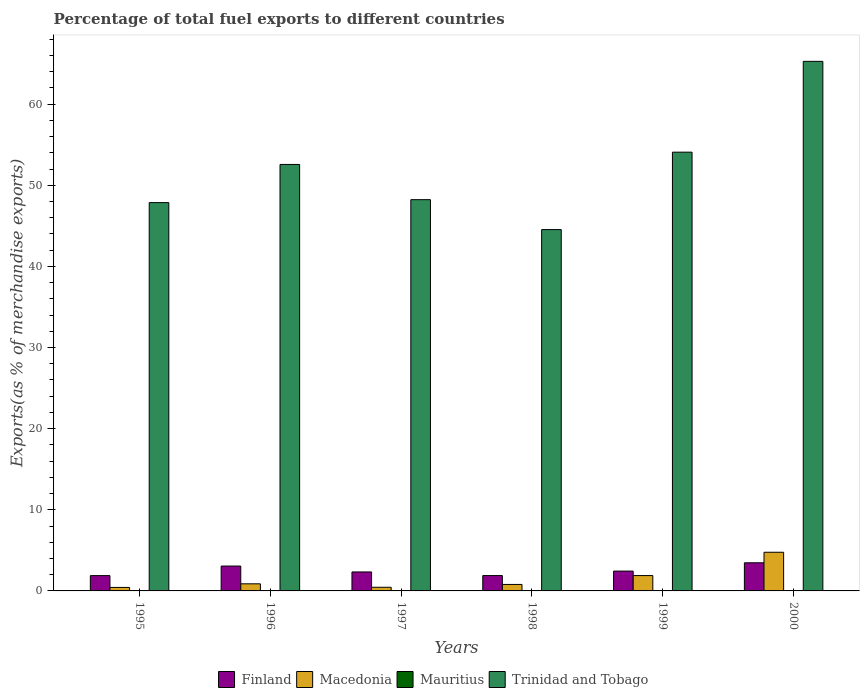How many different coloured bars are there?
Make the answer very short. 4. How many groups of bars are there?
Offer a terse response. 6. Are the number of bars per tick equal to the number of legend labels?
Provide a succinct answer. Yes. What is the label of the 2nd group of bars from the left?
Make the answer very short. 1996. What is the percentage of exports to different countries in Macedonia in 1998?
Give a very brief answer. 0.8. Across all years, what is the maximum percentage of exports to different countries in Finland?
Your response must be concise. 3.47. Across all years, what is the minimum percentage of exports to different countries in Macedonia?
Offer a terse response. 0.43. In which year was the percentage of exports to different countries in Trinidad and Tobago minimum?
Provide a short and direct response. 1998. What is the total percentage of exports to different countries in Trinidad and Tobago in the graph?
Ensure brevity in your answer.  312.57. What is the difference between the percentage of exports to different countries in Trinidad and Tobago in 1995 and that in 1998?
Give a very brief answer. 3.32. What is the difference between the percentage of exports to different countries in Mauritius in 1997 and the percentage of exports to different countries in Finland in 1996?
Offer a very short reply. -3.03. What is the average percentage of exports to different countries in Mauritius per year?
Offer a terse response. 0.02. In the year 1999, what is the difference between the percentage of exports to different countries in Trinidad and Tobago and percentage of exports to different countries in Macedonia?
Provide a succinct answer. 52.19. What is the ratio of the percentage of exports to different countries in Mauritius in 1997 to that in 2000?
Your response must be concise. 4.1. What is the difference between the highest and the second highest percentage of exports to different countries in Trinidad and Tobago?
Ensure brevity in your answer.  11.19. What is the difference between the highest and the lowest percentage of exports to different countries in Finland?
Give a very brief answer. 1.58. Is it the case that in every year, the sum of the percentage of exports to different countries in Macedonia and percentage of exports to different countries in Trinidad and Tobago is greater than the sum of percentage of exports to different countries in Finland and percentage of exports to different countries in Mauritius?
Ensure brevity in your answer.  Yes. What does the 3rd bar from the right in 2000 represents?
Offer a very short reply. Macedonia. Are all the bars in the graph horizontal?
Offer a terse response. No. Are the values on the major ticks of Y-axis written in scientific E-notation?
Make the answer very short. No. Where does the legend appear in the graph?
Make the answer very short. Bottom center. What is the title of the graph?
Make the answer very short. Percentage of total fuel exports to different countries. What is the label or title of the X-axis?
Provide a succinct answer. Years. What is the label or title of the Y-axis?
Ensure brevity in your answer.  Exports(as % of merchandise exports). What is the Exports(as % of merchandise exports) of Finland in 1995?
Provide a succinct answer. 1.89. What is the Exports(as % of merchandise exports) in Macedonia in 1995?
Give a very brief answer. 0.43. What is the Exports(as % of merchandise exports) in Mauritius in 1995?
Offer a terse response. 0.01. What is the Exports(as % of merchandise exports) in Trinidad and Tobago in 1995?
Give a very brief answer. 47.87. What is the Exports(as % of merchandise exports) of Finland in 1996?
Your answer should be very brief. 3.06. What is the Exports(as % of merchandise exports) of Macedonia in 1996?
Give a very brief answer. 0.88. What is the Exports(as % of merchandise exports) of Mauritius in 1996?
Your response must be concise. 7.544697945039909e-5. What is the Exports(as % of merchandise exports) in Trinidad and Tobago in 1996?
Offer a terse response. 52.57. What is the Exports(as % of merchandise exports) of Finland in 1997?
Your response must be concise. 2.34. What is the Exports(as % of merchandise exports) of Macedonia in 1997?
Give a very brief answer. 0.45. What is the Exports(as % of merchandise exports) in Mauritius in 1997?
Make the answer very short. 0.03. What is the Exports(as % of merchandise exports) in Trinidad and Tobago in 1997?
Make the answer very short. 48.23. What is the Exports(as % of merchandise exports) in Finland in 1998?
Offer a terse response. 1.89. What is the Exports(as % of merchandise exports) of Macedonia in 1998?
Your answer should be very brief. 0.8. What is the Exports(as % of merchandise exports) in Mauritius in 1998?
Keep it short and to the point. 0.05. What is the Exports(as % of merchandise exports) of Trinidad and Tobago in 1998?
Make the answer very short. 44.54. What is the Exports(as % of merchandise exports) of Finland in 1999?
Offer a very short reply. 2.45. What is the Exports(as % of merchandise exports) in Macedonia in 1999?
Give a very brief answer. 1.89. What is the Exports(as % of merchandise exports) of Mauritius in 1999?
Ensure brevity in your answer.  0. What is the Exports(as % of merchandise exports) of Trinidad and Tobago in 1999?
Your answer should be compact. 54.08. What is the Exports(as % of merchandise exports) in Finland in 2000?
Give a very brief answer. 3.47. What is the Exports(as % of merchandise exports) of Macedonia in 2000?
Provide a short and direct response. 4.77. What is the Exports(as % of merchandise exports) in Mauritius in 2000?
Provide a short and direct response. 0.01. What is the Exports(as % of merchandise exports) of Trinidad and Tobago in 2000?
Make the answer very short. 65.28. Across all years, what is the maximum Exports(as % of merchandise exports) of Finland?
Ensure brevity in your answer.  3.47. Across all years, what is the maximum Exports(as % of merchandise exports) of Macedonia?
Offer a very short reply. 4.77. Across all years, what is the maximum Exports(as % of merchandise exports) in Mauritius?
Offer a very short reply. 0.05. Across all years, what is the maximum Exports(as % of merchandise exports) in Trinidad and Tobago?
Ensure brevity in your answer.  65.28. Across all years, what is the minimum Exports(as % of merchandise exports) of Finland?
Give a very brief answer. 1.89. Across all years, what is the minimum Exports(as % of merchandise exports) in Macedonia?
Ensure brevity in your answer.  0.43. Across all years, what is the minimum Exports(as % of merchandise exports) in Mauritius?
Keep it short and to the point. 7.544697945039909e-5. Across all years, what is the minimum Exports(as % of merchandise exports) of Trinidad and Tobago?
Your answer should be compact. 44.54. What is the total Exports(as % of merchandise exports) of Finland in the graph?
Your answer should be compact. 15.1. What is the total Exports(as % of merchandise exports) in Macedonia in the graph?
Provide a succinct answer. 9.21. What is the total Exports(as % of merchandise exports) of Mauritius in the graph?
Your answer should be very brief. 0.1. What is the total Exports(as % of merchandise exports) of Trinidad and Tobago in the graph?
Ensure brevity in your answer.  312.57. What is the difference between the Exports(as % of merchandise exports) of Finland in 1995 and that in 1996?
Your response must be concise. -1.18. What is the difference between the Exports(as % of merchandise exports) of Macedonia in 1995 and that in 1996?
Ensure brevity in your answer.  -0.45. What is the difference between the Exports(as % of merchandise exports) in Mauritius in 1995 and that in 1996?
Ensure brevity in your answer.  0.01. What is the difference between the Exports(as % of merchandise exports) of Trinidad and Tobago in 1995 and that in 1996?
Keep it short and to the point. -4.7. What is the difference between the Exports(as % of merchandise exports) in Finland in 1995 and that in 1997?
Your answer should be very brief. -0.45. What is the difference between the Exports(as % of merchandise exports) of Macedonia in 1995 and that in 1997?
Offer a very short reply. -0.02. What is the difference between the Exports(as % of merchandise exports) in Mauritius in 1995 and that in 1997?
Give a very brief answer. -0.03. What is the difference between the Exports(as % of merchandise exports) of Trinidad and Tobago in 1995 and that in 1997?
Offer a terse response. -0.36. What is the difference between the Exports(as % of merchandise exports) in Finland in 1995 and that in 1998?
Make the answer very short. -0.01. What is the difference between the Exports(as % of merchandise exports) of Macedonia in 1995 and that in 1998?
Your answer should be compact. -0.37. What is the difference between the Exports(as % of merchandise exports) in Mauritius in 1995 and that in 1998?
Provide a short and direct response. -0.04. What is the difference between the Exports(as % of merchandise exports) in Trinidad and Tobago in 1995 and that in 1998?
Your answer should be very brief. 3.32. What is the difference between the Exports(as % of merchandise exports) in Finland in 1995 and that in 1999?
Offer a terse response. -0.56. What is the difference between the Exports(as % of merchandise exports) of Macedonia in 1995 and that in 1999?
Provide a succinct answer. -1.46. What is the difference between the Exports(as % of merchandise exports) of Mauritius in 1995 and that in 1999?
Keep it short and to the point. 0.01. What is the difference between the Exports(as % of merchandise exports) of Trinidad and Tobago in 1995 and that in 1999?
Provide a succinct answer. -6.22. What is the difference between the Exports(as % of merchandise exports) in Finland in 1995 and that in 2000?
Make the answer very short. -1.58. What is the difference between the Exports(as % of merchandise exports) in Macedonia in 1995 and that in 2000?
Ensure brevity in your answer.  -4.34. What is the difference between the Exports(as % of merchandise exports) of Mauritius in 1995 and that in 2000?
Ensure brevity in your answer.  -0. What is the difference between the Exports(as % of merchandise exports) in Trinidad and Tobago in 1995 and that in 2000?
Your answer should be compact. -17.41. What is the difference between the Exports(as % of merchandise exports) in Finland in 1996 and that in 1997?
Ensure brevity in your answer.  0.72. What is the difference between the Exports(as % of merchandise exports) of Macedonia in 1996 and that in 1997?
Provide a succinct answer. 0.43. What is the difference between the Exports(as % of merchandise exports) of Mauritius in 1996 and that in 1997?
Your answer should be compact. -0.03. What is the difference between the Exports(as % of merchandise exports) in Trinidad and Tobago in 1996 and that in 1997?
Keep it short and to the point. 4.34. What is the difference between the Exports(as % of merchandise exports) of Finland in 1996 and that in 1998?
Keep it short and to the point. 1.17. What is the difference between the Exports(as % of merchandise exports) of Macedonia in 1996 and that in 1998?
Make the answer very short. 0.08. What is the difference between the Exports(as % of merchandise exports) in Mauritius in 1996 and that in 1998?
Ensure brevity in your answer.  -0.05. What is the difference between the Exports(as % of merchandise exports) of Trinidad and Tobago in 1996 and that in 1998?
Keep it short and to the point. 8.03. What is the difference between the Exports(as % of merchandise exports) of Finland in 1996 and that in 1999?
Your answer should be very brief. 0.62. What is the difference between the Exports(as % of merchandise exports) in Macedonia in 1996 and that in 1999?
Keep it short and to the point. -1.02. What is the difference between the Exports(as % of merchandise exports) of Mauritius in 1996 and that in 1999?
Offer a terse response. -0. What is the difference between the Exports(as % of merchandise exports) in Trinidad and Tobago in 1996 and that in 1999?
Keep it short and to the point. -1.52. What is the difference between the Exports(as % of merchandise exports) of Finland in 1996 and that in 2000?
Provide a succinct answer. -0.4. What is the difference between the Exports(as % of merchandise exports) in Macedonia in 1996 and that in 2000?
Provide a succinct answer. -3.89. What is the difference between the Exports(as % of merchandise exports) in Mauritius in 1996 and that in 2000?
Provide a succinct answer. -0.01. What is the difference between the Exports(as % of merchandise exports) of Trinidad and Tobago in 1996 and that in 2000?
Offer a very short reply. -12.71. What is the difference between the Exports(as % of merchandise exports) in Finland in 1997 and that in 1998?
Your answer should be compact. 0.45. What is the difference between the Exports(as % of merchandise exports) in Macedonia in 1997 and that in 1998?
Offer a very short reply. -0.35. What is the difference between the Exports(as % of merchandise exports) of Mauritius in 1997 and that in 1998?
Ensure brevity in your answer.  -0.02. What is the difference between the Exports(as % of merchandise exports) of Trinidad and Tobago in 1997 and that in 1998?
Offer a very short reply. 3.69. What is the difference between the Exports(as % of merchandise exports) in Finland in 1997 and that in 1999?
Give a very brief answer. -0.11. What is the difference between the Exports(as % of merchandise exports) of Macedonia in 1997 and that in 1999?
Your answer should be very brief. -1.44. What is the difference between the Exports(as % of merchandise exports) of Mauritius in 1997 and that in 1999?
Give a very brief answer. 0.03. What is the difference between the Exports(as % of merchandise exports) of Trinidad and Tobago in 1997 and that in 1999?
Make the answer very short. -5.86. What is the difference between the Exports(as % of merchandise exports) of Finland in 1997 and that in 2000?
Your answer should be compact. -1.13. What is the difference between the Exports(as % of merchandise exports) of Macedonia in 1997 and that in 2000?
Keep it short and to the point. -4.32. What is the difference between the Exports(as % of merchandise exports) of Mauritius in 1997 and that in 2000?
Provide a succinct answer. 0.03. What is the difference between the Exports(as % of merchandise exports) in Trinidad and Tobago in 1997 and that in 2000?
Provide a succinct answer. -17.05. What is the difference between the Exports(as % of merchandise exports) of Finland in 1998 and that in 1999?
Your answer should be compact. -0.55. What is the difference between the Exports(as % of merchandise exports) in Macedonia in 1998 and that in 1999?
Provide a short and direct response. -1.1. What is the difference between the Exports(as % of merchandise exports) of Mauritius in 1998 and that in 1999?
Provide a short and direct response. 0.05. What is the difference between the Exports(as % of merchandise exports) of Trinidad and Tobago in 1998 and that in 1999?
Offer a terse response. -9.54. What is the difference between the Exports(as % of merchandise exports) of Finland in 1998 and that in 2000?
Make the answer very short. -1.57. What is the difference between the Exports(as % of merchandise exports) of Macedonia in 1998 and that in 2000?
Make the answer very short. -3.97. What is the difference between the Exports(as % of merchandise exports) of Mauritius in 1998 and that in 2000?
Provide a short and direct response. 0.04. What is the difference between the Exports(as % of merchandise exports) of Trinidad and Tobago in 1998 and that in 2000?
Make the answer very short. -20.74. What is the difference between the Exports(as % of merchandise exports) of Finland in 1999 and that in 2000?
Keep it short and to the point. -1.02. What is the difference between the Exports(as % of merchandise exports) in Macedonia in 1999 and that in 2000?
Provide a succinct answer. -2.87. What is the difference between the Exports(as % of merchandise exports) of Mauritius in 1999 and that in 2000?
Your answer should be very brief. -0.01. What is the difference between the Exports(as % of merchandise exports) in Trinidad and Tobago in 1999 and that in 2000?
Keep it short and to the point. -11.19. What is the difference between the Exports(as % of merchandise exports) in Finland in 1995 and the Exports(as % of merchandise exports) in Macedonia in 1996?
Offer a very short reply. 1.01. What is the difference between the Exports(as % of merchandise exports) of Finland in 1995 and the Exports(as % of merchandise exports) of Mauritius in 1996?
Keep it short and to the point. 1.89. What is the difference between the Exports(as % of merchandise exports) in Finland in 1995 and the Exports(as % of merchandise exports) in Trinidad and Tobago in 1996?
Offer a very short reply. -50.68. What is the difference between the Exports(as % of merchandise exports) in Macedonia in 1995 and the Exports(as % of merchandise exports) in Mauritius in 1996?
Offer a terse response. 0.43. What is the difference between the Exports(as % of merchandise exports) of Macedonia in 1995 and the Exports(as % of merchandise exports) of Trinidad and Tobago in 1996?
Keep it short and to the point. -52.14. What is the difference between the Exports(as % of merchandise exports) in Mauritius in 1995 and the Exports(as % of merchandise exports) in Trinidad and Tobago in 1996?
Give a very brief answer. -52.56. What is the difference between the Exports(as % of merchandise exports) in Finland in 1995 and the Exports(as % of merchandise exports) in Macedonia in 1997?
Your answer should be very brief. 1.44. What is the difference between the Exports(as % of merchandise exports) in Finland in 1995 and the Exports(as % of merchandise exports) in Mauritius in 1997?
Your response must be concise. 1.85. What is the difference between the Exports(as % of merchandise exports) of Finland in 1995 and the Exports(as % of merchandise exports) of Trinidad and Tobago in 1997?
Offer a terse response. -46.34. What is the difference between the Exports(as % of merchandise exports) in Macedonia in 1995 and the Exports(as % of merchandise exports) in Mauritius in 1997?
Make the answer very short. 0.4. What is the difference between the Exports(as % of merchandise exports) in Macedonia in 1995 and the Exports(as % of merchandise exports) in Trinidad and Tobago in 1997?
Provide a short and direct response. -47.8. What is the difference between the Exports(as % of merchandise exports) of Mauritius in 1995 and the Exports(as % of merchandise exports) of Trinidad and Tobago in 1997?
Provide a short and direct response. -48.22. What is the difference between the Exports(as % of merchandise exports) in Finland in 1995 and the Exports(as % of merchandise exports) in Macedonia in 1998?
Make the answer very short. 1.09. What is the difference between the Exports(as % of merchandise exports) of Finland in 1995 and the Exports(as % of merchandise exports) of Mauritius in 1998?
Your answer should be compact. 1.84. What is the difference between the Exports(as % of merchandise exports) in Finland in 1995 and the Exports(as % of merchandise exports) in Trinidad and Tobago in 1998?
Give a very brief answer. -42.65. What is the difference between the Exports(as % of merchandise exports) of Macedonia in 1995 and the Exports(as % of merchandise exports) of Mauritius in 1998?
Ensure brevity in your answer.  0.38. What is the difference between the Exports(as % of merchandise exports) in Macedonia in 1995 and the Exports(as % of merchandise exports) in Trinidad and Tobago in 1998?
Provide a short and direct response. -44.11. What is the difference between the Exports(as % of merchandise exports) in Mauritius in 1995 and the Exports(as % of merchandise exports) in Trinidad and Tobago in 1998?
Offer a very short reply. -44.53. What is the difference between the Exports(as % of merchandise exports) in Finland in 1995 and the Exports(as % of merchandise exports) in Macedonia in 1999?
Your response must be concise. -0.01. What is the difference between the Exports(as % of merchandise exports) in Finland in 1995 and the Exports(as % of merchandise exports) in Mauritius in 1999?
Offer a very short reply. 1.89. What is the difference between the Exports(as % of merchandise exports) of Finland in 1995 and the Exports(as % of merchandise exports) of Trinidad and Tobago in 1999?
Provide a succinct answer. -52.2. What is the difference between the Exports(as % of merchandise exports) of Macedonia in 1995 and the Exports(as % of merchandise exports) of Mauritius in 1999?
Ensure brevity in your answer.  0.43. What is the difference between the Exports(as % of merchandise exports) of Macedonia in 1995 and the Exports(as % of merchandise exports) of Trinidad and Tobago in 1999?
Make the answer very short. -53.65. What is the difference between the Exports(as % of merchandise exports) in Mauritius in 1995 and the Exports(as % of merchandise exports) in Trinidad and Tobago in 1999?
Give a very brief answer. -54.08. What is the difference between the Exports(as % of merchandise exports) in Finland in 1995 and the Exports(as % of merchandise exports) in Macedonia in 2000?
Ensure brevity in your answer.  -2.88. What is the difference between the Exports(as % of merchandise exports) of Finland in 1995 and the Exports(as % of merchandise exports) of Mauritius in 2000?
Ensure brevity in your answer.  1.88. What is the difference between the Exports(as % of merchandise exports) of Finland in 1995 and the Exports(as % of merchandise exports) of Trinidad and Tobago in 2000?
Make the answer very short. -63.39. What is the difference between the Exports(as % of merchandise exports) in Macedonia in 1995 and the Exports(as % of merchandise exports) in Mauritius in 2000?
Provide a short and direct response. 0.42. What is the difference between the Exports(as % of merchandise exports) of Macedonia in 1995 and the Exports(as % of merchandise exports) of Trinidad and Tobago in 2000?
Offer a terse response. -64.85. What is the difference between the Exports(as % of merchandise exports) in Mauritius in 1995 and the Exports(as % of merchandise exports) in Trinidad and Tobago in 2000?
Your response must be concise. -65.27. What is the difference between the Exports(as % of merchandise exports) of Finland in 1996 and the Exports(as % of merchandise exports) of Macedonia in 1997?
Offer a very short reply. 2.62. What is the difference between the Exports(as % of merchandise exports) of Finland in 1996 and the Exports(as % of merchandise exports) of Mauritius in 1997?
Your answer should be compact. 3.03. What is the difference between the Exports(as % of merchandise exports) of Finland in 1996 and the Exports(as % of merchandise exports) of Trinidad and Tobago in 1997?
Keep it short and to the point. -45.16. What is the difference between the Exports(as % of merchandise exports) in Macedonia in 1996 and the Exports(as % of merchandise exports) in Mauritius in 1997?
Your answer should be very brief. 0.84. What is the difference between the Exports(as % of merchandise exports) of Macedonia in 1996 and the Exports(as % of merchandise exports) of Trinidad and Tobago in 1997?
Give a very brief answer. -47.35. What is the difference between the Exports(as % of merchandise exports) in Mauritius in 1996 and the Exports(as % of merchandise exports) in Trinidad and Tobago in 1997?
Offer a very short reply. -48.23. What is the difference between the Exports(as % of merchandise exports) of Finland in 1996 and the Exports(as % of merchandise exports) of Macedonia in 1998?
Offer a terse response. 2.27. What is the difference between the Exports(as % of merchandise exports) in Finland in 1996 and the Exports(as % of merchandise exports) in Mauritius in 1998?
Provide a short and direct response. 3.01. What is the difference between the Exports(as % of merchandise exports) of Finland in 1996 and the Exports(as % of merchandise exports) of Trinidad and Tobago in 1998?
Offer a very short reply. -41.48. What is the difference between the Exports(as % of merchandise exports) of Macedonia in 1996 and the Exports(as % of merchandise exports) of Mauritius in 1998?
Your answer should be very brief. 0.82. What is the difference between the Exports(as % of merchandise exports) in Macedonia in 1996 and the Exports(as % of merchandise exports) in Trinidad and Tobago in 1998?
Offer a terse response. -43.67. What is the difference between the Exports(as % of merchandise exports) of Mauritius in 1996 and the Exports(as % of merchandise exports) of Trinidad and Tobago in 1998?
Make the answer very short. -44.54. What is the difference between the Exports(as % of merchandise exports) in Finland in 1996 and the Exports(as % of merchandise exports) in Macedonia in 1999?
Keep it short and to the point. 1.17. What is the difference between the Exports(as % of merchandise exports) of Finland in 1996 and the Exports(as % of merchandise exports) of Mauritius in 1999?
Your answer should be compact. 3.06. What is the difference between the Exports(as % of merchandise exports) of Finland in 1996 and the Exports(as % of merchandise exports) of Trinidad and Tobago in 1999?
Your answer should be very brief. -51.02. What is the difference between the Exports(as % of merchandise exports) of Macedonia in 1996 and the Exports(as % of merchandise exports) of Mauritius in 1999?
Your response must be concise. 0.87. What is the difference between the Exports(as % of merchandise exports) of Macedonia in 1996 and the Exports(as % of merchandise exports) of Trinidad and Tobago in 1999?
Your answer should be compact. -53.21. What is the difference between the Exports(as % of merchandise exports) in Mauritius in 1996 and the Exports(as % of merchandise exports) in Trinidad and Tobago in 1999?
Keep it short and to the point. -54.08. What is the difference between the Exports(as % of merchandise exports) of Finland in 1996 and the Exports(as % of merchandise exports) of Macedonia in 2000?
Make the answer very short. -1.7. What is the difference between the Exports(as % of merchandise exports) in Finland in 1996 and the Exports(as % of merchandise exports) in Mauritius in 2000?
Offer a terse response. 3.06. What is the difference between the Exports(as % of merchandise exports) of Finland in 1996 and the Exports(as % of merchandise exports) of Trinidad and Tobago in 2000?
Make the answer very short. -62.21. What is the difference between the Exports(as % of merchandise exports) of Macedonia in 1996 and the Exports(as % of merchandise exports) of Mauritius in 2000?
Your answer should be very brief. 0.87. What is the difference between the Exports(as % of merchandise exports) of Macedonia in 1996 and the Exports(as % of merchandise exports) of Trinidad and Tobago in 2000?
Your answer should be very brief. -64.4. What is the difference between the Exports(as % of merchandise exports) of Mauritius in 1996 and the Exports(as % of merchandise exports) of Trinidad and Tobago in 2000?
Make the answer very short. -65.28. What is the difference between the Exports(as % of merchandise exports) of Finland in 1997 and the Exports(as % of merchandise exports) of Macedonia in 1998?
Keep it short and to the point. 1.54. What is the difference between the Exports(as % of merchandise exports) in Finland in 1997 and the Exports(as % of merchandise exports) in Mauritius in 1998?
Provide a succinct answer. 2.29. What is the difference between the Exports(as % of merchandise exports) in Finland in 1997 and the Exports(as % of merchandise exports) in Trinidad and Tobago in 1998?
Your answer should be compact. -42.2. What is the difference between the Exports(as % of merchandise exports) in Macedonia in 1997 and the Exports(as % of merchandise exports) in Mauritius in 1998?
Make the answer very short. 0.4. What is the difference between the Exports(as % of merchandise exports) in Macedonia in 1997 and the Exports(as % of merchandise exports) in Trinidad and Tobago in 1998?
Keep it short and to the point. -44.09. What is the difference between the Exports(as % of merchandise exports) in Mauritius in 1997 and the Exports(as % of merchandise exports) in Trinidad and Tobago in 1998?
Make the answer very short. -44.51. What is the difference between the Exports(as % of merchandise exports) in Finland in 1997 and the Exports(as % of merchandise exports) in Macedonia in 1999?
Your answer should be compact. 0.45. What is the difference between the Exports(as % of merchandise exports) of Finland in 1997 and the Exports(as % of merchandise exports) of Mauritius in 1999?
Provide a short and direct response. 2.34. What is the difference between the Exports(as % of merchandise exports) of Finland in 1997 and the Exports(as % of merchandise exports) of Trinidad and Tobago in 1999?
Offer a terse response. -51.74. What is the difference between the Exports(as % of merchandise exports) of Macedonia in 1997 and the Exports(as % of merchandise exports) of Mauritius in 1999?
Your answer should be very brief. 0.45. What is the difference between the Exports(as % of merchandise exports) in Macedonia in 1997 and the Exports(as % of merchandise exports) in Trinidad and Tobago in 1999?
Offer a very short reply. -53.64. What is the difference between the Exports(as % of merchandise exports) in Mauritius in 1997 and the Exports(as % of merchandise exports) in Trinidad and Tobago in 1999?
Your answer should be compact. -54.05. What is the difference between the Exports(as % of merchandise exports) in Finland in 1997 and the Exports(as % of merchandise exports) in Macedonia in 2000?
Offer a very short reply. -2.43. What is the difference between the Exports(as % of merchandise exports) of Finland in 1997 and the Exports(as % of merchandise exports) of Mauritius in 2000?
Your answer should be compact. 2.33. What is the difference between the Exports(as % of merchandise exports) of Finland in 1997 and the Exports(as % of merchandise exports) of Trinidad and Tobago in 2000?
Provide a succinct answer. -62.94. What is the difference between the Exports(as % of merchandise exports) in Macedonia in 1997 and the Exports(as % of merchandise exports) in Mauritius in 2000?
Keep it short and to the point. 0.44. What is the difference between the Exports(as % of merchandise exports) of Macedonia in 1997 and the Exports(as % of merchandise exports) of Trinidad and Tobago in 2000?
Provide a succinct answer. -64.83. What is the difference between the Exports(as % of merchandise exports) of Mauritius in 1997 and the Exports(as % of merchandise exports) of Trinidad and Tobago in 2000?
Provide a succinct answer. -65.24. What is the difference between the Exports(as % of merchandise exports) in Finland in 1998 and the Exports(as % of merchandise exports) in Macedonia in 1999?
Give a very brief answer. -0. What is the difference between the Exports(as % of merchandise exports) in Finland in 1998 and the Exports(as % of merchandise exports) in Mauritius in 1999?
Provide a short and direct response. 1.89. What is the difference between the Exports(as % of merchandise exports) of Finland in 1998 and the Exports(as % of merchandise exports) of Trinidad and Tobago in 1999?
Make the answer very short. -52.19. What is the difference between the Exports(as % of merchandise exports) in Macedonia in 1998 and the Exports(as % of merchandise exports) in Mauritius in 1999?
Your response must be concise. 0.8. What is the difference between the Exports(as % of merchandise exports) of Macedonia in 1998 and the Exports(as % of merchandise exports) of Trinidad and Tobago in 1999?
Provide a short and direct response. -53.29. What is the difference between the Exports(as % of merchandise exports) in Mauritius in 1998 and the Exports(as % of merchandise exports) in Trinidad and Tobago in 1999?
Offer a terse response. -54.03. What is the difference between the Exports(as % of merchandise exports) of Finland in 1998 and the Exports(as % of merchandise exports) of Macedonia in 2000?
Your answer should be very brief. -2.87. What is the difference between the Exports(as % of merchandise exports) in Finland in 1998 and the Exports(as % of merchandise exports) in Mauritius in 2000?
Offer a very short reply. 1.88. What is the difference between the Exports(as % of merchandise exports) in Finland in 1998 and the Exports(as % of merchandise exports) in Trinidad and Tobago in 2000?
Make the answer very short. -63.39. What is the difference between the Exports(as % of merchandise exports) of Macedonia in 1998 and the Exports(as % of merchandise exports) of Mauritius in 2000?
Your answer should be compact. 0.79. What is the difference between the Exports(as % of merchandise exports) of Macedonia in 1998 and the Exports(as % of merchandise exports) of Trinidad and Tobago in 2000?
Give a very brief answer. -64.48. What is the difference between the Exports(as % of merchandise exports) of Mauritius in 1998 and the Exports(as % of merchandise exports) of Trinidad and Tobago in 2000?
Offer a terse response. -65.23. What is the difference between the Exports(as % of merchandise exports) of Finland in 1999 and the Exports(as % of merchandise exports) of Macedonia in 2000?
Your answer should be compact. -2.32. What is the difference between the Exports(as % of merchandise exports) in Finland in 1999 and the Exports(as % of merchandise exports) in Mauritius in 2000?
Your answer should be very brief. 2.44. What is the difference between the Exports(as % of merchandise exports) in Finland in 1999 and the Exports(as % of merchandise exports) in Trinidad and Tobago in 2000?
Ensure brevity in your answer.  -62.83. What is the difference between the Exports(as % of merchandise exports) in Macedonia in 1999 and the Exports(as % of merchandise exports) in Mauritius in 2000?
Your response must be concise. 1.89. What is the difference between the Exports(as % of merchandise exports) in Macedonia in 1999 and the Exports(as % of merchandise exports) in Trinidad and Tobago in 2000?
Offer a very short reply. -63.38. What is the difference between the Exports(as % of merchandise exports) in Mauritius in 1999 and the Exports(as % of merchandise exports) in Trinidad and Tobago in 2000?
Your answer should be compact. -65.28. What is the average Exports(as % of merchandise exports) of Finland per year?
Your answer should be compact. 2.52. What is the average Exports(as % of merchandise exports) of Macedonia per year?
Your response must be concise. 1.54. What is the average Exports(as % of merchandise exports) of Mauritius per year?
Your answer should be very brief. 0.02. What is the average Exports(as % of merchandise exports) of Trinidad and Tobago per year?
Your answer should be compact. 52.09. In the year 1995, what is the difference between the Exports(as % of merchandise exports) in Finland and Exports(as % of merchandise exports) in Macedonia?
Make the answer very short. 1.46. In the year 1995, what is the difference between the Exports(as % of merchandise exports) of Finland and Exports(as % of merchandise exports) of Mauritius?
Ensure brevity in your answer.  1.88. In the year 1995, what is the difference between the Exports(as % of merchandise exports) in Finland and Exports(as % of merchandise exports) in Trinidad and Tobago?
Keep it short and to the point. -45.98. In the year 1995, what is the difference between the Exports(as % of merchandise exports) of Macedonia and Exports(as % of merchandise exports) of Mauritius?
Keep it short and to the point. 0.42. In the year 1995, what is the difference between the Exports(as % of merchandise exports) in Macedonia and Exports(as % of merchandise exports) in Trinidad and Tobago?
Make the answer very short. -47.44. In the year 1995, what is the difference between the Exports(as % of merchandise exports) of Mauritius and Exports(as % of merchandise exports) of Trinidad and Tobago?
Provide a succinct answer. -47.86. In the year 1996, what is the difference between the Exports(as % of merchandise exports) of Finland and Exports(as % of merchandise exports) of Macedonia?
Your answer should be compact. 2.19. In the year 1996, what is the difference between the Exports(as % of merchandise exports) of Finland and Exports(as % of merchandise exports) of Mauritius?
Your answer should be compact. 3.06. In the year 1996, what is the difference between the Exports(as % of merchandise exports) in Finland and Exports(as % of merchandise exports) in Trinidad and Tobago?
Your response must be concise. -49.5. In the year 1996, what is the difference between the Exports(as % of merchandise exports) of Macedonia and Exports(as % of merchandise exports) of Mauritius?
Offer a very short reply. 0.88. In the year 1996, what is the difference between the Exports(as % of merchandise exports) of Macedonia and Exports(as % of merchandise exports) of Trinidad and Tobago?
Your answer should be compact. -51.69. In the year 1996, what is the difference between the Exports(as % of merchandise exports) in Mauritius and Exports(as % of merchandise exports) in Trinidad and Tobago?
Ensure brevity in your answer.  -52.57. In the year 1997, what is the difference between the Exports(as % of merchandise exports) in Finland and Exports(as % of merchandise exports) in Macedonia?
Your response must be concise. 1.89. In the year 1997, what is the difference between the Exports(as % of merchandise exports) in Finland and Exports(as % of merchandise exports) in Mauritius?
Provide a succinct answer. 2.31. In the year 1997, what is the difference between the Exports(as % of merchandise exports) in Finland and Exports(as % of merchandise exports) in Trinidad and Tobago?
Offer a very short reply. -45.89. In the year 1997, what is the difference between the Exports(as % of merchandise exports) in Macedonia and Exports(as % of merchandise exports) in Mauritius?
Your answer should be compact. 0.42. In the year 1997, what is the difference between the Exports(as % of merchandise exports) in Macedonia and Exports(as % of merchandise exports) in Trinidad and Tobago?
Ensure brevity in your answer.  -47.78. In the year 1997, what is the difference between the Exports(as % of merchandise exports) in Mauritius and Exports(as % of merchandise exports) in Trinidad and Tobago?
Your response must be concise. -48.19. In the year 1998, what is the difference between the Exports(as % of merchandise exports) in Finland and Exports(as % of merchandise exports) in Macedonia?
Offer a very short reply. 1.09. In the year 1998, what is the difference between the Exports(as % of merchandise exports) in Finland and Exports(as % of merchandise exports) in Mauritius?
Provide a succinct answer. 1.84. In the year 1998, what is the difference between the Exports(as % of merchandise exports) of Finland and Exports(as % of merchandise exports) of Trinidad and Tobago?
Your answer should be very brief. -42.65. In the year 1998, what is the difference between the Exports(as % of merchandise exports) in Macedonia and Exports(as % of merchandise exports) in Mauritius?
Provide a short and direct response. 0.75. In the year 1998, what is the difference between the Exports(as % of merchandise exports) in Macedonia and Exports(as % of merchandise exports) in Trinidad and Tobago?
Offer a very short reply. -43.74. In the year 1998, what is the difference between the Exports(as % of merchandise exports) in Mauritius and Exports(as % of merchandise exports) in Trinidad and Tobago?
Your response must be concise. -44.49. In the year 1999, what is the difference between the Exports(as % of merchandise exports) in Finland and Exports(as % of merchandise exports) in Macedonia?
Offer a very short reply. 0.55. In the year 1999, what is the difference between the Exports(as % of merchandise exports) in Finland and Exports(as % of merchandise exports) in Mauritius?
Make the answer very short. 2.44. In the year 1999, what is the difference between the Exports(as % of merchandise exports) of Finland and Exports(as % of merchandise exports) of Trinidad and Tobago?
Make the answer very short. -51.64. In the year 1999, what is the difference between the Exports(as % of merchandise exports) in Macedonia and Exports(as % of merchandise exports) in Mauritius?
Your answer should be very brief. 1.89. In the year 1999, what is the difference between the Exports(as % of merchandise exports) in Macedonia and Exports(as % of merchandise exports) in Trinidad and Tobago?
Your answer should be compact. -52.19. In the year 1999, what is the difference between the Exports(as % of merchandise exports) of Mauritius and Exports(as % of merchandise exports) of Trinidad and Tobago?
Keep it short and to the point. -54.08. In the year 2000, what is the difference between the Exports(as % of merchandise exports) of Finland and Exports(as % of merchandise exports) of Macedonia?
Make the answer very short. -1.3. In the year 2000, what is the difference between the Exports(as % of merchandise exports) in Finland and Exports(as % of merchandise exports) in Mauritius?
Your response must be concise. 3.46. In the year 2000, what is the difference between the Exports(as % of merchandise exports) of Finland and Exports(as % of merchandise exports) of Trinidad and Tobago?
Offer a terse response. -61.81. In the year 2000, what is the difference between the Exports(as % of merchandise exports) in Macedonia and Exports(as % of merchandise exports) in Mauritius?
Provide a succinct answer. 4.76. In the year 2000, what is the difference between the Exports(as % of merchandise exports) of Macedonia and Exports(as % of merchandise exports) of Trinidad and Tobago?
Your response must be concise. -60.51. In the year 2000, what is the difference between the Exports(as % of merchandise exports) in Mauritius and Exports(as % of merchandise exports) in Trinidad and Tobago?
Your answer should be very brief. -65.27. What is the ratio of the Exports(as % of merchandise exports) in Finland in 1995 to that in 1996?
Provide a succinct answer. 0.62. What is the ratio of the Exports(as % of merchandise exports) of Macedonia in 1995 to that in 1996?
Make the answer very short. 0.49. What is the ratio of the Exports(as % of merchandise exports) in Mauritius in 1995 to that in 1996?
Provide a short and direct response. 98.57. What is the ratio of the Exports(as % of merchandise exports) in Trinidad and Tobago in 1995 to that in 1996?
Offer a terse response. 0.91. What is the ratio of the Exports(as % of merchandise exports) of Finland in 1995 to that in 1997?
Provide a succinct answer. 0.81. What is the ratio of the Exports(as % of merchandise exports) in Macedonia in 1995 to that in 1997?
Provide a succinct answer. 0.96. What is the ratio of the Exports(as % of merchandise exports) in Mauritius in 1995 to that in 1997?
Offer a very short reply. 0.22. What is the ratio of the Exports(as % of merchandise exports) of Trinidad and Tobago in 1995 to that in 1997?
Make the answer very short. 0.99. What is the ratio of the Exports(as % of merchandise exports) of Finland in 1995 to that in 1998?
Give a very brief answer. 1. What is the ratio of the Exports(as % of merchandise exports) of Macedonia in 1995 to that in 1998?
Provide a succinct answer. 0.54. What is the ratio of the Exports(as % of merchandise exports) of Mauritius in 1995 to that in 1998?
Offer a terse response. 0.15. What is the ratio of the Exports(as % of merchandise exports) of Trinidad and Tobago in 1995 to that in 1998?
Ensure brevity in your answer.  1.07. What is the ratio of the Exports(as % of merchandise exports) in Finland in 1995 to that in 1999?
Your answer should be very brief. 0.77. What is the ratio of the Exports(as % of merchandise exports) of Macedonia in 1995 to that in 1999?
Offer a very short reply. 0.23. What is the ratio of the Exports(as % of merchandise exports) in Mauritius in 1995 to that in 1999?
Your response must be concise. 5.86. What is the ratio of the Exports(as % of merchandise exports) of Trinidad and Tobago in 1995 to that in 1999?
Your response must be concise. 0.89. What is the ratio of the Exports(as % of merchandise exports) of Finland in 1995 to that in 2000?
Your answer should be very brief. 0.54. What is the ratio of the Exports(as % of merchandise exports) of Macedonia in 1995 to that in 2000?
Make the answer very short. 0.09. What is the ratio of the Exports(as % of merchandise exports) of Mauritius in 1995 to that in 2000?
Provide a succinct answer. 0.9. What is the ratio of the Exports(as % of merchandise exports) in Trinidad and Tobago in 1995 to that in 2000?
Make the answer very short. 0.73. What is the ratio of the Exports(as % of merchandise exports) of Finland in 1996 to that in 1997?
Your response must be concise. 1.31. What is the ratio of the Exports(as % of merchandise exports) of Macedonia in 1996 to that in 1997?
Give a very brief answer. 1.95. What is the ratio of the Exports(as % of merchandise exports) of Mauritius in 1996 to that in 1997?
Give a very brief answer. 0. What is the ratio of the Exports(as % of merchandise exports) of Trinidad and Tobago in 1996 to that in 1997?
Give a very brief answer. 1.09. What is the ratio of the Exports(as % of merchandise exports) of Finland in 1996 to that in 1998?
Your response must be concise. 1.62. What is the ratio of the Exports(as % of merchandise exports) in Macedonia in 1996 to that in 1998?
Provide a short and direct response. 1.1. What is the ratio of the Exports(as % of merchandise exports) in Mauritius in 1996 to that in 1998?
Provide a short and direct response. 0. What is the ratio of the Exports(as % of merchandise exports) of Trinidad and Tobago in 1996 to that in 1998?
Your answer should be very brief. 1.18. What is the ratio of the Exports(as % of merchandise exports) of Finland in 1996 to that in 1999?
Provide a succinct answer. 1.25. What is the ratio of the Exports(as % of merchandise exports) of Macedonia in 1996 to that in 1999?
Provide a short and direct response. 0.46. What is the ratio of the Exports(as % of merchandise exports) of Mauritius in 1996 to that in 1999?
Offer a very short reply. 0.06. What is the ratio of the Exports(as % of merchandise exports) of Finland in 1996 to that in 2000?
Offer a terse response. 0.88. What is the ratio of the Exports(as % of merchandise exports) in Macedonia in 1996 to that in 2000?
Your response must be concise. 0.18. What is the ratio of the Exports(as % of merchandise exports) of Mauritius in 1996 to that in 2000?
Keep it short and to the point. 0.01. What is the ratio of the Exports(as % of merchandise exports) of Trinidad and Tobago in 1996 to that in 2000?
Ensure brevity in your answer.  0.81. What is the ratio of the Exports(as % of merchandise exports) of Finland in 1997 to that in 1998?
Your answer should be compact. 1.24. What is the ratio of the Exports(as % of merchandise exports) in Macedonia in 1997 to that in 1998?
Offer a terse response. 0.56. What is the ratio of the Exports(as % of merchandise exports) of Mauritius in 1997 to that in 1998?
Offer a terse response. 0.67. What is the ratio of the Exports(as % of merchandise exports) in Trinidad and Tobago in 1997 to that in 1998?
Provide a succinct answer. 1.08. What is the ratio of the Exports(as % of merchandise exports) of Finland in 1997 to that in 1999?
Offer a terse response. 0.96. What is the ratio of the Exports(as % of merchandise exports) of Macedonia in 1997 to that in 1999?
Keep it short and to the point. 0.24. What is the ratio of the Exports(as % of merchandise exports) of Mauritius in 1997 to that in 1999?
Your answer should be compact. 26.56. What is the ratio of the Exports(as % of merchandise exports) in Trinidad and Tobago in 1997 to that in 1999?
Keep it short and to the point. 0.89. What is the ratio of the Exports(as % of merchandise exports) of Finland in 1997 to that in 2000?
Your answer should be compact. 0.68. What is the ratio of the Exports(as % of merchandise exports) in Macedonia in 1997 to that in 2000?
Offer a very short reply. 0.09. What is the ratio of the Exports(as % of merchandise exports) of Mauritius in 1997 to that in 2000?
Give a very brief answer. 4.1. What is the ratio of the Exports(as % of merchandise exports) of Trinidad and Tobago in 1997 to that in 2000?
Your response must be concise. 0.74. What is the ratio of the Exports(as % of merchandise exports) in Finland in 1998 to that in 1999?
Provide a succinct answer. 0.77. What is the ratio of the Exports(as % of merchandise exports) in Macedonia in 1998 to that in 1999?
Make the answer very short. 0.42. What is the ratio of the Exports(as % of merchandise exports) of Mauritius in 1998 to that in 1999?
Your response must be concise. 39.67. What is the ratio of the Exports(as % of merchandise exports) of Trinidad and Tobago in 1998 to that in 1999?
Keep it short and to the point. 0.82. What is the ratio of the Exports(as % of merchandise exports) of Finland in 1998 to that in 2000?
Make the answer very short. 0.55. What is the ratio of the Exports(as % of merchandise exports) of Macedonia in 1998 to that in 2000?
Keep it short and to the point. 0.17. What is the ratio of the Exports(as % of merchandise exports) in Mauritius in 1998 to that in 2000?
Your answer should be compact. 6.12. What is the ratio of the Exports(as % of merchandise exports) of Trinidad and Tobago in 1998 to that in 2000?
Your response must be concise. 0.68. What is the ratio of the Exports(as % of merchandise exports) in Finland in 1999 to that in 2000?
Make the answer very short. 0.71. What is the ratio of the Exports(as % of merchandise exports) of Macedonia in 1999 to that in 2000?
Keep it short and to the point. 0.4. What is the ratio of the Exports(as % of merchandise exports) in Mauritius in 1999 to that in 2000?
Your answer should be very brief. 0.15. What is the ratio of the Exports(as % of merchandise exports) of Trinidad and Tobago in 1999 to that in 2000?
Keep it short and to the point. 0.83. What is the difference between the highest and the second highest Exports(as % of merchandise exports) in Finland?
Give a very brief answer. 0.4. What is the difference between the highest and the second highest Exports(as % of merchandise exports) of Macedonia?
Offer a terse response. 2.87. What is the difference between the highest and the second highest Exports(as % of merchandise exports) of Mauritius?
Your answer should be very brief. 0.02. What is the difference between the highest and the second highest Exports(as % of merchandise exports) in Trinidad and Tobago?
Your answer should be very brief. 11.19. What is the difference between the highest and the lowest Exports(as % of merchandise exports) of Finland?
Your answer should be compact. 1.58. What is the difference between the highest and the lowest Exports(as % of merchandise exports) in Macedonia?
Offer a terse response. 4.34. What is the difference between the highest and the lowest Exports(as % of merchandise exports) in Mauritius?
Ensure brevity in your answer.  0.05. What is the difference between the highest and the lowest Exports(as % of merchandise exports) of Trinidad and Tobago?
Keep it short and to the point. 20.74. 